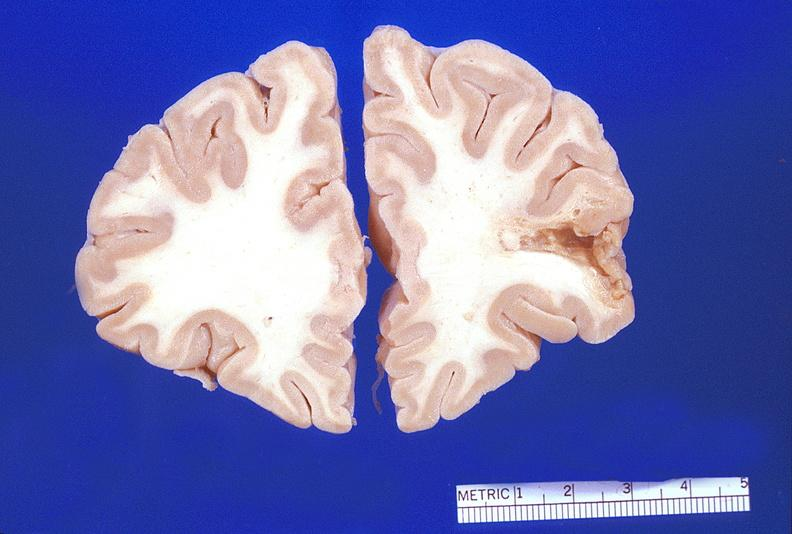s this image shows of smooth muscle cell with lipid in sarcoplasm and lipid present?
Answer the question using a single word or phrase. No 